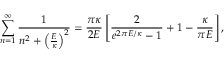Convert formula to latex. <formula><loc_0><loc_0><loc_500><loc_500>\sum _ { n = 1 } ^ { \infty } { \frac { 1 } { n ^ { 2 } + \left ( { \frac { E } { \kappa } } \right ) ^ { 2 } } } = { \frac { \pi \kappa } { 2 E } } \left [ { \frac { 2 } { e ^ { 2 \pi E / \kappa } - 1 } } + 1 - { \frac { \kappa } { \pi E } } \right ] ,</formula> 